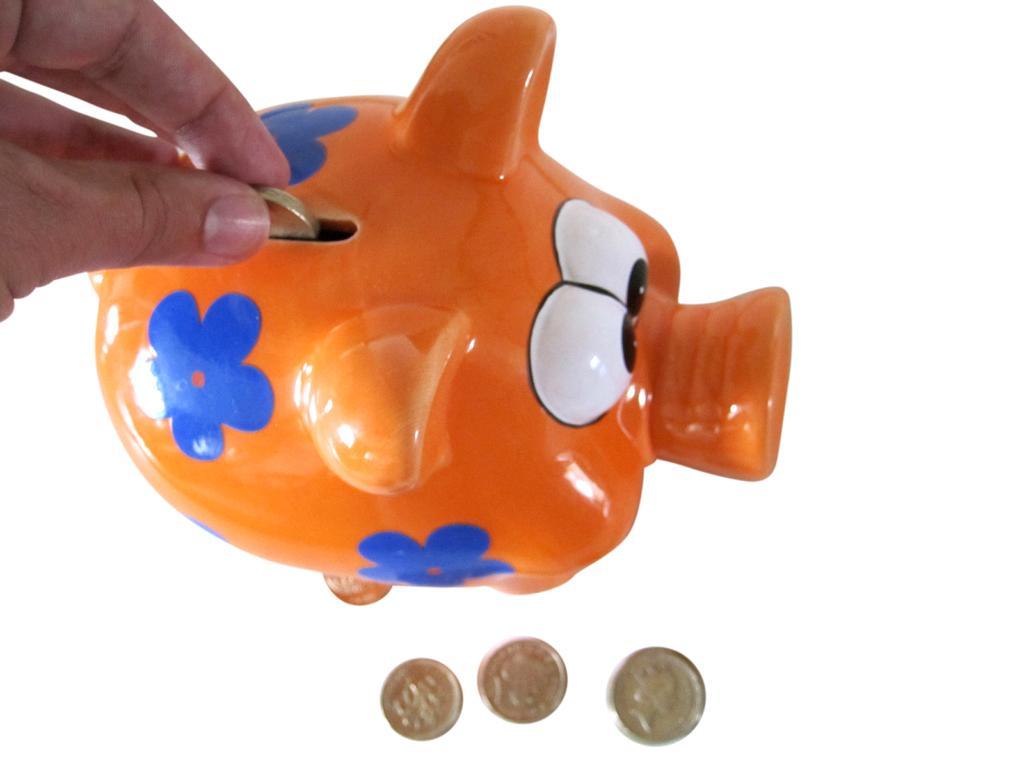Describe this image in one or two sentences. In this image I can see a piggy bank and a person's hand putting coins into the piggy bank and some coins besides the piggy bank. 